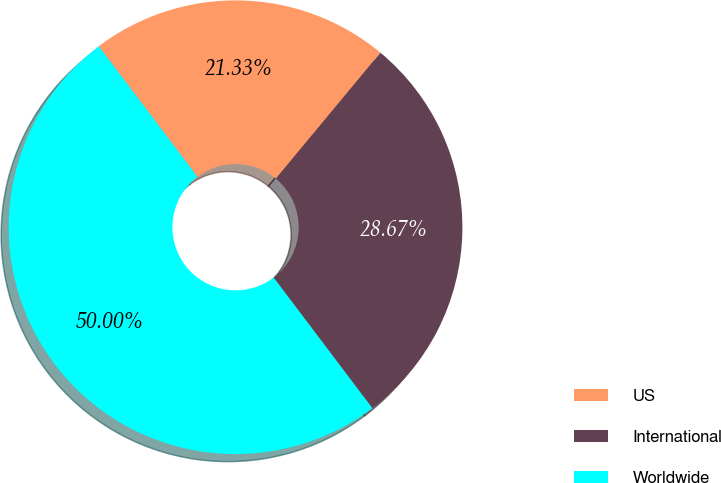Convert chart to OTSL. <chart><loc_0><loc_0><loc_500><loc_500><pie_chart><fcel>US<fcel>International<fcel>Worldwide<nl><fcel>21.33%<fcel>28.67%<fcel>50.0%<nl></chart> 